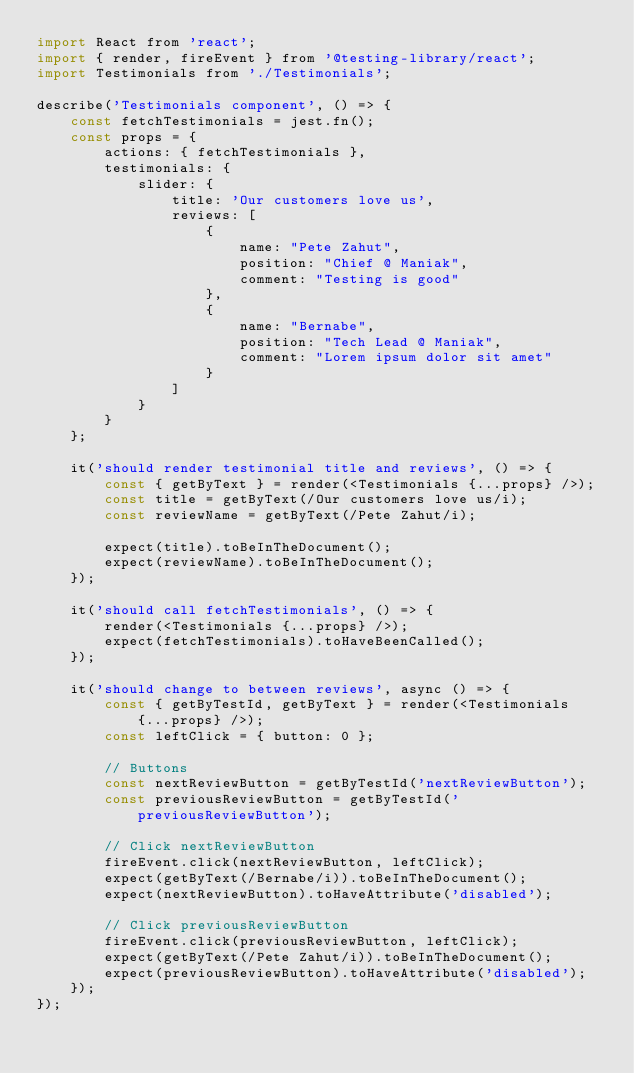Convert code to text. <code><loc_0><loc_0><loc_500><loc_500><_JavaScript_>import React from 'react';
import { render, fireEvent } from '@testing-library/react';
import Testimonials from './Testimonials';

describe('Testimonials component', () => {
    const fetchTestimonials = jest.fn();
    const props = {
        actions: { fetchTestimonials },
        testimonials: {
            slider: {
                title: 'Our customers love us',
                reviews: [
                    {
                        name: "Pete Zahut",
                        position: "Chief @ Maniak",
                        comment: "Testing is good"
                    },
                    {
                        name: "Bernabe",
                        position: "Tech Lead @ Maniak",
                        comment: "Lorem ipsum dolor sit amet"
                    }
                ]
            }
        }
    };

    it('should render testimonial title and reviews', () => {
        const { getByText } = render(<Testimonials {...props} />);
        const title = getByText(/Our customers love us/i);
        const reviewName = getByText(/Pete Zahut/i);
        
        expect(title).toBeInTheDocument();
        expect(reviewName).toBeInTheDocument();
    });

    it('should call fetchTestimonials', () => {
        render(<Testimonials {...props} />);
        expect(fetchTestimonials).toHaveBeenCalled();
    });

    it('should change to between reviews', async () => {
        const { getByTestId, getByText } = render(<Testimonials {...props} />);
        const leftClick = { button: 0 };

        // Buttons
        const nextReviewButton = getByTestId('nextReviewButton');
        const previousReviewButton = getByTestId('previousReviewButton');

        // Click nextReviewButton
        fireEvent.click(nextReviewButton, leftClick);
        expect(getByText(/Bernabe/i)).toBeInTheDocument();
        expect(nextReviewButton).toHaveAttribute('disabled');

        // Click previousReviewButton
        fireEvent.click(previousReviewButton, leftClick);
        expect(getByText(/Pete Zahut/i)).toBeInTheDocument();
        expect(previousReviewButton).toHaveAttribute('disabled');
    });
});
</code> 